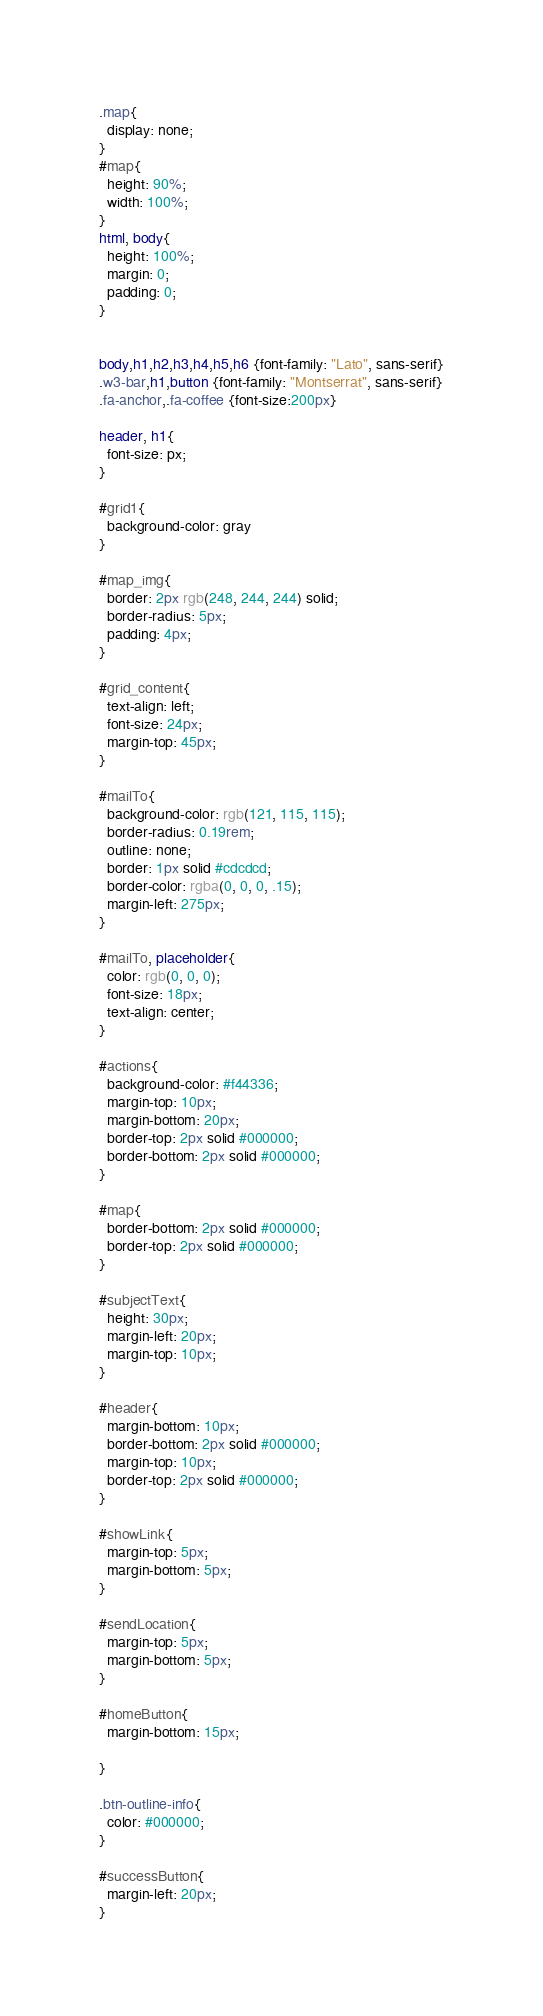<code> <loc_0><loc_0><loc_500><loc_500><_CSS_>
.map{
  display: none;
}
#map{
  height: 90%;
  width: 100%;
}
html, body{
  height: 100%;
  margin: 0;
  padding: 0;
}


body,h1,h2,h3,h4,h5,h6 {font-family: "Lato", sans-serif}
.w3-bar,h1,button {font-family: "Montserrat", sans-serif}
.fa-anchor,.fa-coffee {font-size:200px}

header, h1{
  font-size: px;
}

#grid1{
  background-color: gray
}

#map_img{
  border: 2px rgb(248, 244, 244) solid;
  border-radius: 5px;
  padding: 4px;
}

#grid_content{
  text-align: left;
  font-size: 24px;
  margin-top: 45px;
}

#mailTo{
  background-color: rgb(121, 115, 115);
  border-radius: 0.19rem;
  outline: none;
  border: 1px solid #cdcdcd;
  border-color: rgba(0, 0, 0, .15);
  margin-left: 275px;
}

#mailTo, placeholder{
  color: rgb(0, 0, 0);
  font-size: 18px;
  text-align: center;
}

#actions{
  background-color: #f44336;
  margin-top: 10px;
  margin-bottom: 20px;
  border-top: 2px solid #000000;
  border-bottom: 2px solid #000000;
}

#map{
  border-bottom: 2px solid #000000;
  border-top: 2px solid #000000;
}

#subjectText{
  height: 30px;
  margin-left: 20px;
  margin-top: 10px;
}

#header{
  margin-bottom: 10px;
  border-bottom: 2px solid #000000;
  margin-top: 10px;
  border-top: 2px solid #000000;
}

#showLink{
  margin-top: 5px;
  margin-bottom: 5px;
}

#sendLocation{
  margin-top: 5px;
  margin-bottom: 5px;
}

#homeButton{
  margin-bottom: 15px;
  
}

.btn-outline-info{
  color: #000000;
}

#successButton{
  margin-left: 20px;
}</code> 